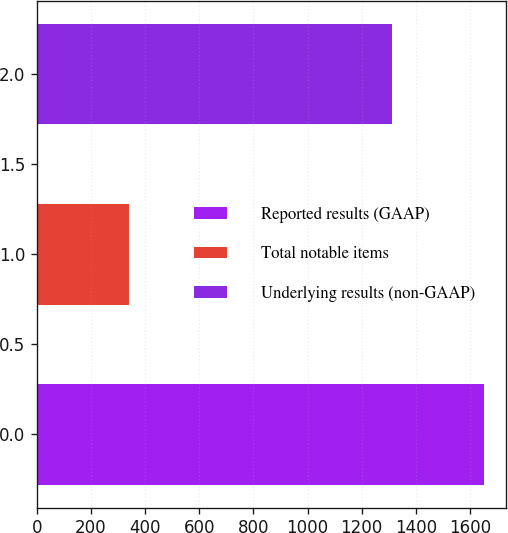Convert chart. <chart><loc_0><loc_0><loc_500><loc_500><bar_chart><fcel>Reported results (GAAP)<fcel>Total notable items<fcel>Underlying results (non-GAAP)<nl><fcel>1652<fcel>340<fcel>1312<nl></chart> 